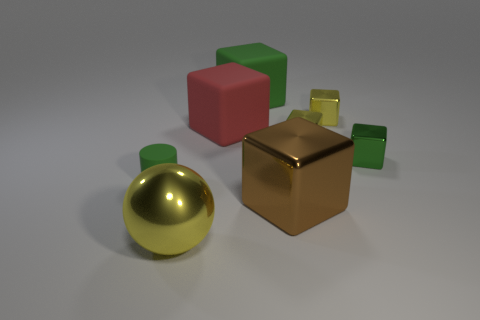Subtract all green metal cubes. How many cubes are left? 5 Subtract 3 blocks. How many blocks are left? 3 Subtract all red blocks. How many blocks are left? 5 Subtract all red cubes. Subtract all cyan balls. How many cubes are left? 5 Add 1 big spheres. How many objects exist? 9 Subtract all balls. How many objects are left? 7 Add 6 large cyan cylinders. How many large cyan cylinders exist? 6 Subtract 0 blue balls. How many objects are left? 8 Subtract all yellow metallic cubes. Subtract all tiny green metal cubes. How many objects are left? 5 Add 3 big green blocks. How many big green blocks are left? 4 